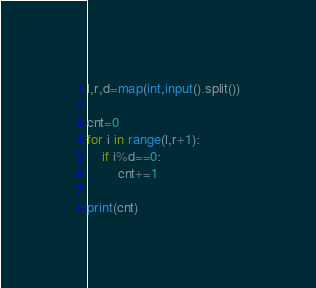Convert code to text. <code><loc_0><loc_0><loc_500><loc_500><_Python_>l,r,d=map(int,input().split())

cnt=0
for i in range(l,r+1):
    if i%d==0:
        cnt+=1

print(cnt)</code> 